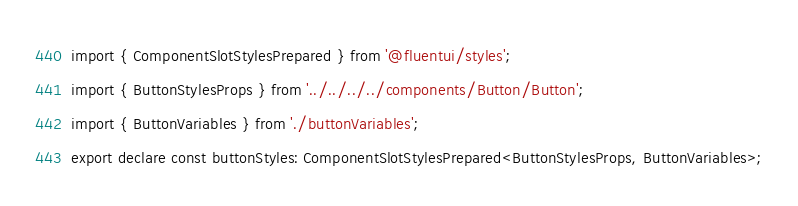Convert code to text. <code><loc_0><loc_0><loc_500><loc_500><_TypeScript_>import { ComponentSlotStylesPrepared } from '@fluentui/styles';
import { ButtonStylesProps } from '../../../../components/Button/Button';
import { ButtonVariables } from './buttonVariables';
export declare const buttonStyles: ComponentSlotStylesPrepared<ButtonStylesProps, ButtonVariables>;
</code> 